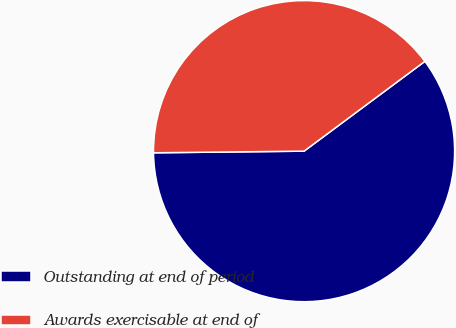Convert chart to OTSL. <chart><loc_0><loc_0><loc_500><loc_500><pie_chart><fcel>Outstanding at end of period<fcel>Awards exercisable at end of<nl><fcel>60.0%<fcel>40.0%<nl></chart> 